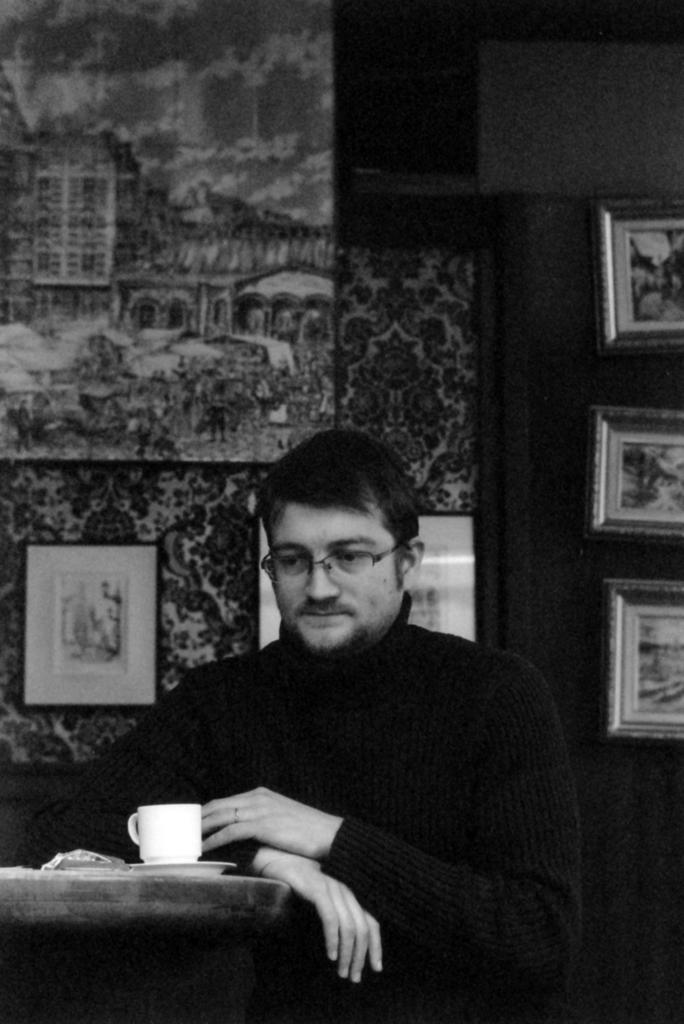Who is present in the image? There is a man in the image. What is on the table in front of the man? There is a cup on the table in front of the man. What can be seen in the background of the image? There is a wall in the background of the image. What is the wall covered with? The wall has wallpaper. What is attached to the wall in the image? Wall hangings are attached to the wall. What is the man's profit from selling the van in the image? There is no van present in the image, and therefore no profit can be determined. 